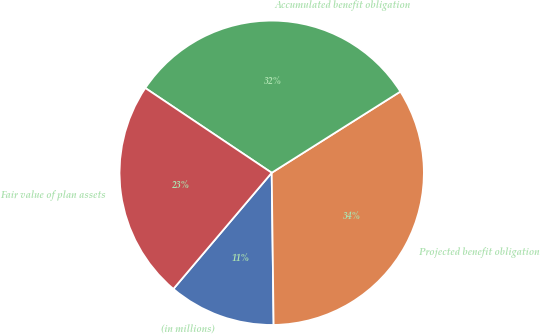Convert chart to OTSL. <chart><loc_0><loc_0><loc_500><loc_500><pie_chart><fcel>(in millions)<fcel>Projected benefit obligation<fcel>Accumulated benefit obligation<fcel>Fair value of plan assets<nl><fcel>11.38%<fcel>33.76%<fcel>31.64%<fcel>23.22%<nl></chart> 